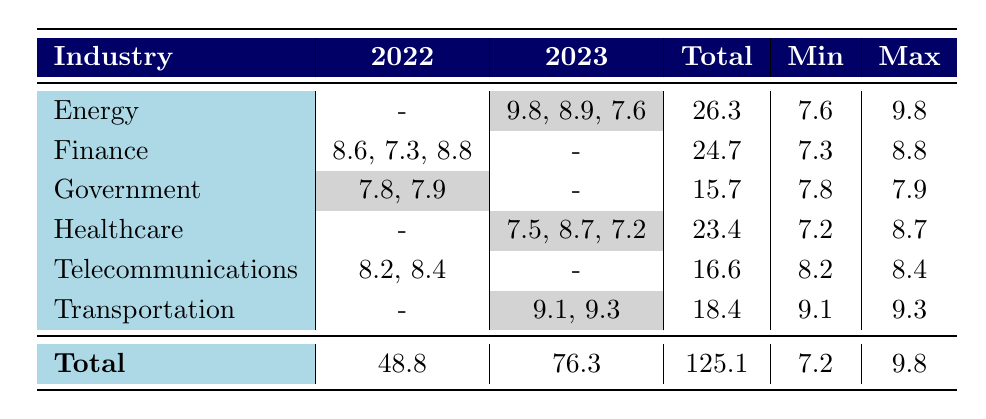What is the maximum vulnerability score in the Energy industry? In the Energy industry, the vulnerability scores in 2023 are listed as 9.8, 8.9, and 7.6. The maximum score is the highest among these values, which is 9.8.
Answer: 9.8 What is the total vulnerability score for the Telecommunications industry? The Telecommunications industry has vulnerability scores of 8.2 and 8.4 in 2022. Adding these values gives 8.2 + 8.4 = 16.6, which is the total for this industry.
Answer: 16.6 Is the average vulnerability score for the Healthcare industry in 2023 greater than 8? The scores for the Healthcare industry in 2023 are 7.5, 8.7, and 7.2. To find the average, we first sum them up: 7.5 + 8.7 + 7.2 = 23.4. Then we divide by the number of scores, which is 3: 23.4/3 = 7.8. Since 7.8 is not greater than 8, the answer is no.
Answer: No Which industry had the least varying vulnerability scores in 2022? The Government industry has scores of 7.8 and 7.9 for 2022, making the range (difference between max and min) equal to 0.1. By comparison, other industries have larger differences between their maximum and minimum scores. Thus, the Government industry shows the least variation.
Answer: Government What is the total number of vulnerability scores recorded in 2022 across all industries? The scores for 2022 are as follows: 8.6 (Finance), 7.3 (Finance), 7.8 (Government), 8.2 (Telecommunications), and 8.4 (Telecommunications). Adding these scores: 8.6 + 7.3 + 7.8 + 8.2 + 8.4 = 48.8 provides the total number of scores for 2022.
Answer: 48.8 Which industry had the highest maximum vulnerability score overall? The comparison shows that the Energy industry has a maximum of 9.8 and Transportation has a maximum of 9.3. Since 9.8 is greater, we conclude that the Energy industry had the highest maximum vulnerability score.
Answer: Energy How many industries have vulnerabilities documented in both years? The industries are Energy, Finance, Government, Healthcare, Telecommunications, and Transportation. Among these, Energy, Finance, Government, and Telecommunications have vulnerabilities listed for 2022, while Healthcare and Transportation only have scores for 2023. Therefore, there are 4 industries with scores documented in both years.
Answer: 4 What is the average CVSS score for the Financial industry? The Financial industry has scores of 8.6, 7.3, and 8.8. Adding these gives 8.6 + 7.3 + 8.8 = 24.7. To find the average, divide by the count of scores, which is 3: 24.7/3 = 8.23. The average is 8.23.
Answer: 8.23 